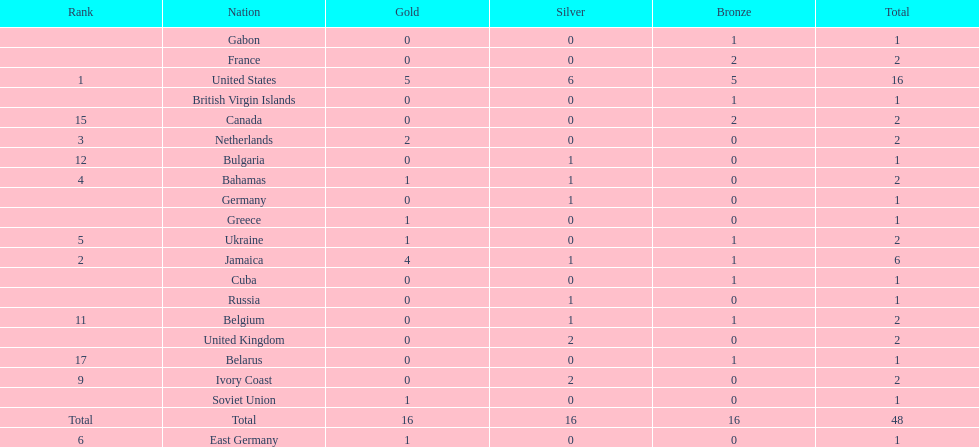How many nations won more than one silver medal? 3. Could you parse the entire table? {'header': ['Rank', 'Nation', 'Gold', 'Silver', 'Bronze', 'Total'], 'rows': [['', 'Gabon', '0', '0', '1', '1'], ['', 'France', '0', '0', '2', '2'], ['1', 'United States', '5', '6', '5', '16'], ['', 'British Virgin Islands', '0', '0', '1', '1'], ['15', 'Canada', '0', '0', '2', '2'], ['3', 'Netherlands', '2', '0', '0', '2'], ['12', 'Bulgaria', '0', '1', '0', '1'], ['4', 'Bahamas', '1', '1', '0', '2'], ['', 'Germany', '0', '1', '0', '1'], ['', 'Greece', '1', '0', '0', '1'], ['5', 'Ukraine', '1', '0', '1', '2'], ['2', 'Jamaica', '4', '1', '1', '6'], ['', 'Cuba', '0', '0', '1', '1'], ['', 'Russia', '0', '1', '0', '1'], ['11', 'Belgium', '0', '1', '1', '2'], ['', 'United Kingdom', '0', '2', '0', '2'], ['17', 'Belarus', '0', '0', '1', '1'], ['9', 'Ivory Coast', '0', '2', '0', '2'], ['', 'Soviet Union', '1', '0', '0', '1'], ['Total', 'Total', '16', '16', '16', '48'], ['6', 'East Germany', '1', '0', '0', '1']]} 